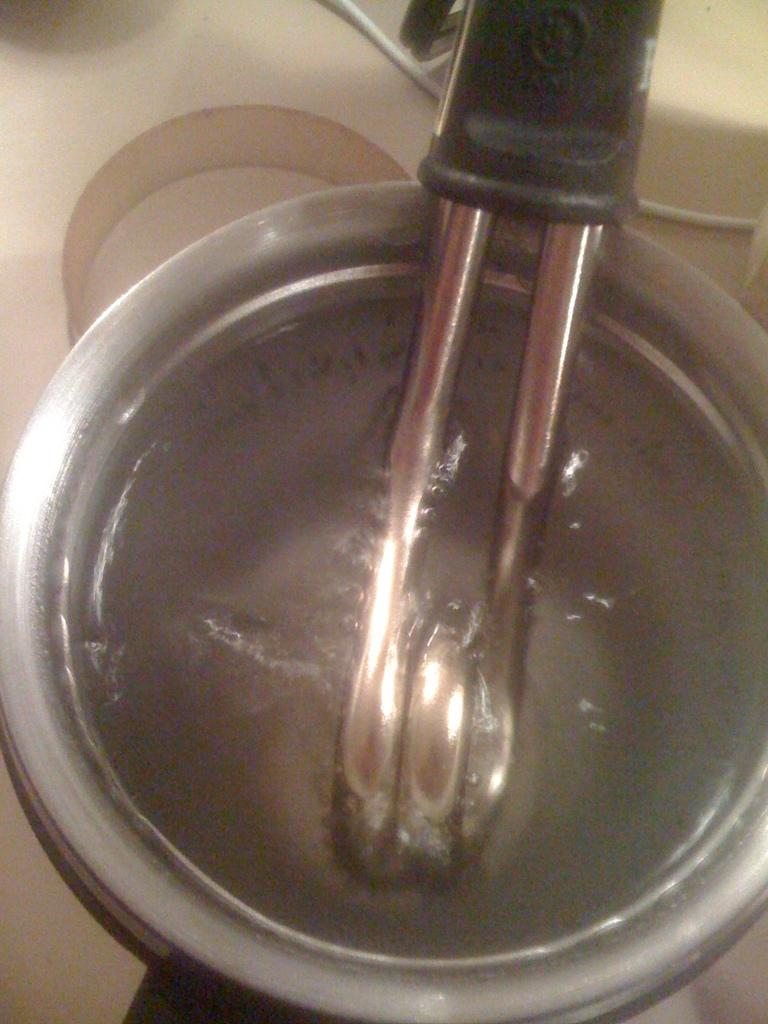What is placed in the bowl in the image? There is a heater in the bowl in the image. What color is the background of the image? The background of the image is white. What type of teeth can be seen on the scarecrow in the image? There is no scarecrow present in the image, and therefore no teeth can be observed. 